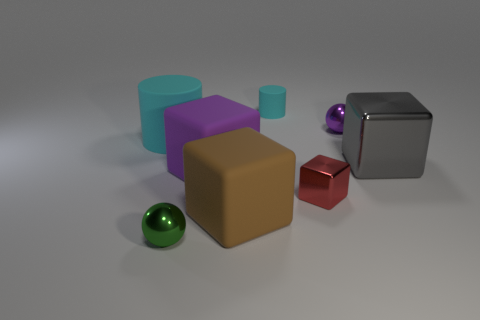Is the material of the cylinder that is to the right of the tiny green shiny ball the same as the large brown cube?
Your answer should be very brief. Yes. There is a cyan rubber cylinder on the left side of the cyan rubber cylinder that is behind the small purple metallic object; what size is it?
Your answer should be compact. Large. What is the color of the tiny object that is right of the tiny cyan matte cylinder and in front of the big cylinder?
Ensure brevity in your answer.  Red. There is a cylinder that is the same size as the gray block; what is its material?
Provide a succinct answer. Rubber. What number of other objects are there of the same material as the big purple cube?
Make the answer very short. 3. Do the small shiny ball that is in front of the gray shiny block and the metallic sphere that is to the right of the tiny block have the same color?
Keep it short and to the point. No. There is a thing left of the shiny ball that is to the left of the brown matte thing; what shape is it?
Make the answer very short. Cylinder. What number of other objects are the same color as the large metal thing?
Offer a very short reply. 0. Are the small ball that is behind the green metal sphere and the cyan cylinder that is on the right side of the small green ball made of the same material?
Give a very brief answer. No. What is the size of the purple thing behind the large gray object?
Your answer should be very brief. Small. 